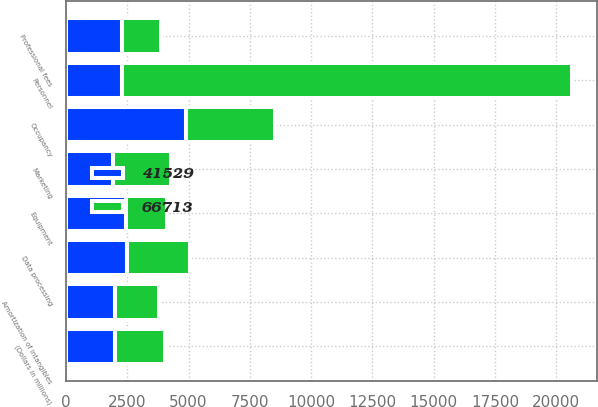<chart> <loc_0><loc_0><loc_500><loc_500><stacked_bar_chart><ecel><fcel>(Dollars in millions)<fcel>Personnel<fcel>Occupancy<fcel>Equipment<fcel>Marketing<fcel>Professional fees<fcel>Amortization of intangibles<fcel>Data processing<nl><fcel>41529<fcel>2009<fcel>2281<fcel>4906<fcel>2455<fcel>1933<fcel>2281<fcel>1978<fcel>2500<nl><fcel>66713<fcel>2008<fcel>18371<fcel>3626<fcel>1655<fcel>2368<fcel>1592<fcel>1834<fcel>2546<nl></chart> 